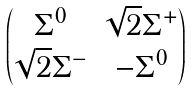<formula> <loc_0><loc_0><loc_500><loc_500>\begin{pmatrix} \Sigma ^ { 0 } & \sqrt { 2 } \Sigma ^ { + } \\ \sqrt { 2 } \Sigma ^ { - } & - \Sigma ^ { 0 } \end{pmatrix}</formula> 